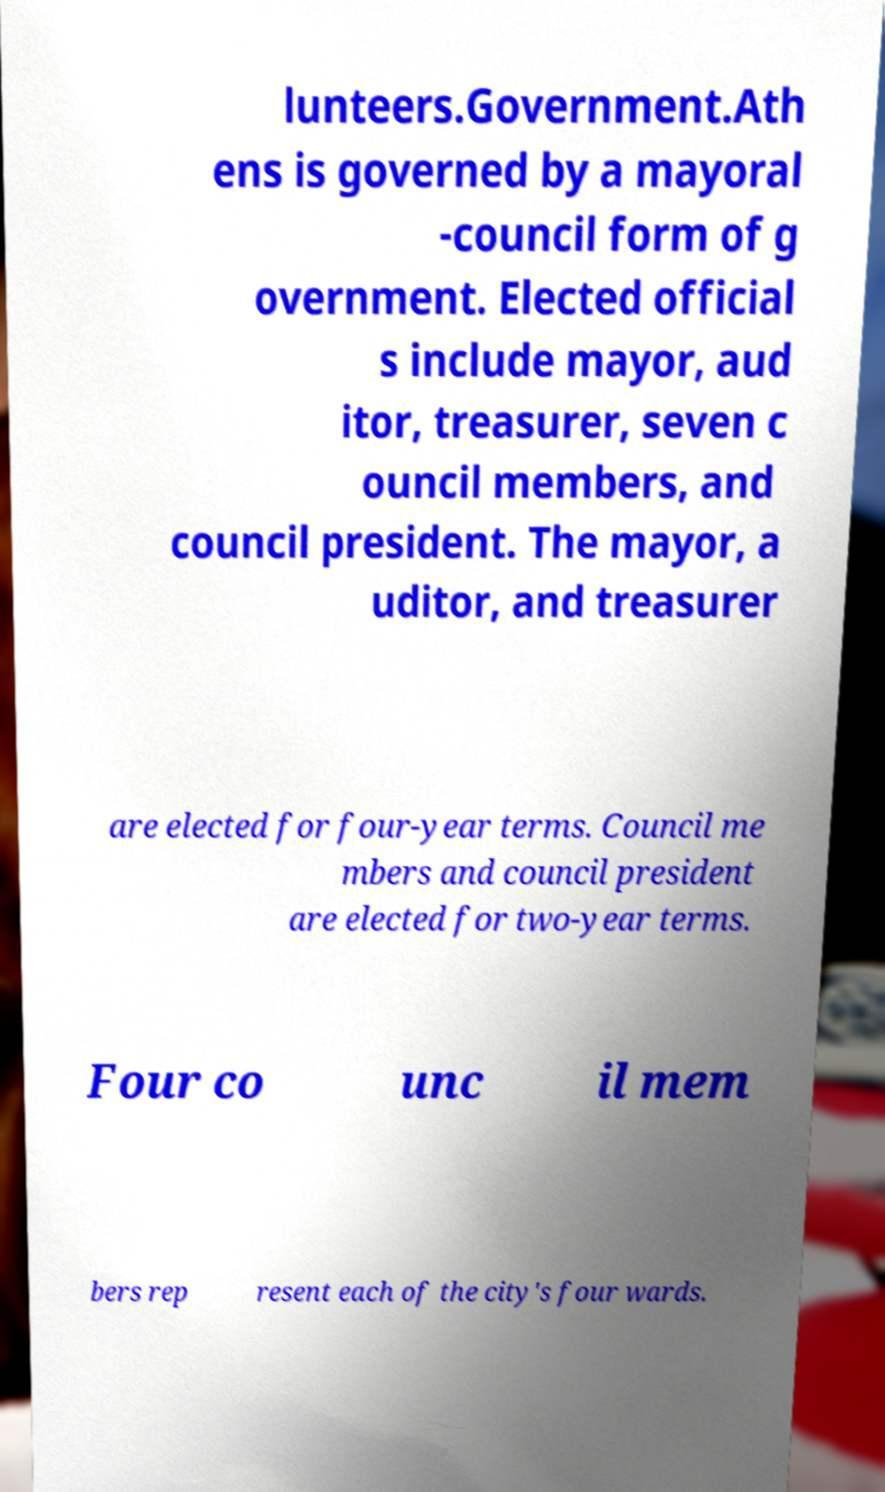For documentation purposes, I need the text within this image transcribed. Could you provide that? lunteers.Government.Ath ens is governed by a mayoral -council form of g overnment. Elected official s include mayor, aud itor, treasurer, seven c ouncil members, and council president. The mayor, a uditor, and treasurer are elected for four-year terms. Council me mbers and council president are elected for two-year terms. Four co unc il mem bers rep resent each of the city's four wards. 